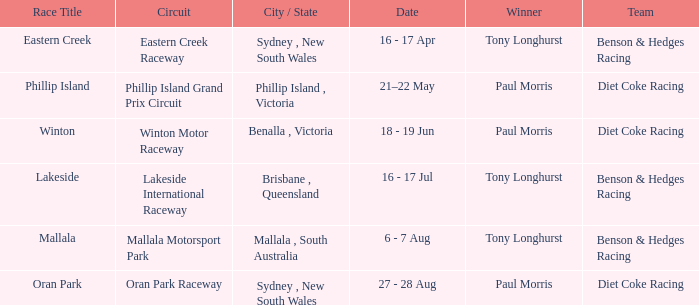When did the mallala race take place? 6 - 7 Aug. 